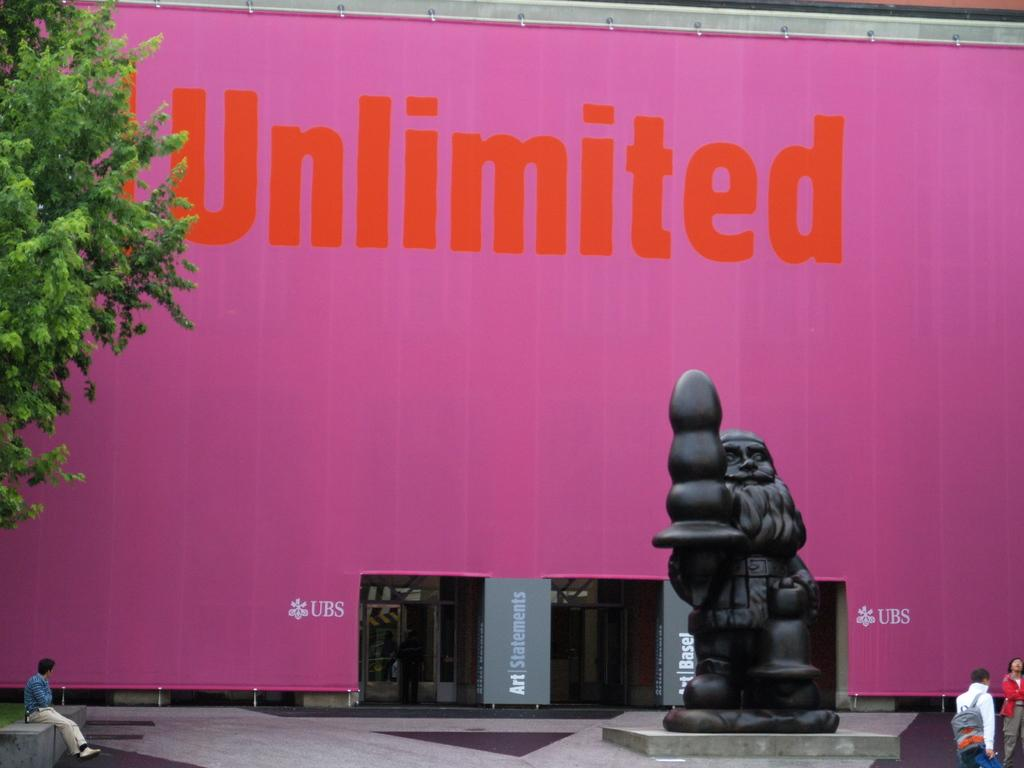What type of surface can be seen in the image? There is ground visible in the image. Who or what is present in the image? There are people and a statue in the image. What is written or depicted on the wall in the image? There is a wall with text in the image. What architectural features are present in the image? There are doors in the image. What type of argument is taking place between the mice in the image? There are no mice present in the image, so no argument can be observed. 